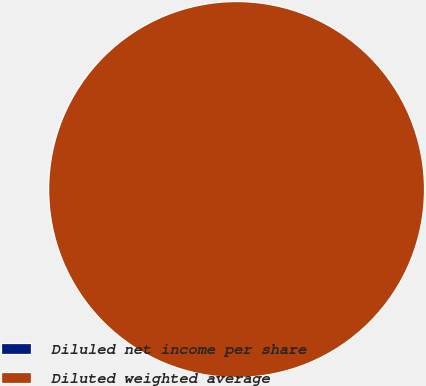<chart> <loc_0><loc_0><loc_500><loc_500><pie_chart><fcel>Diluled net income per share<fcel>Diluted weighted average<nl><fcel>0.0%<fcel>100.0%<nl></chart> 